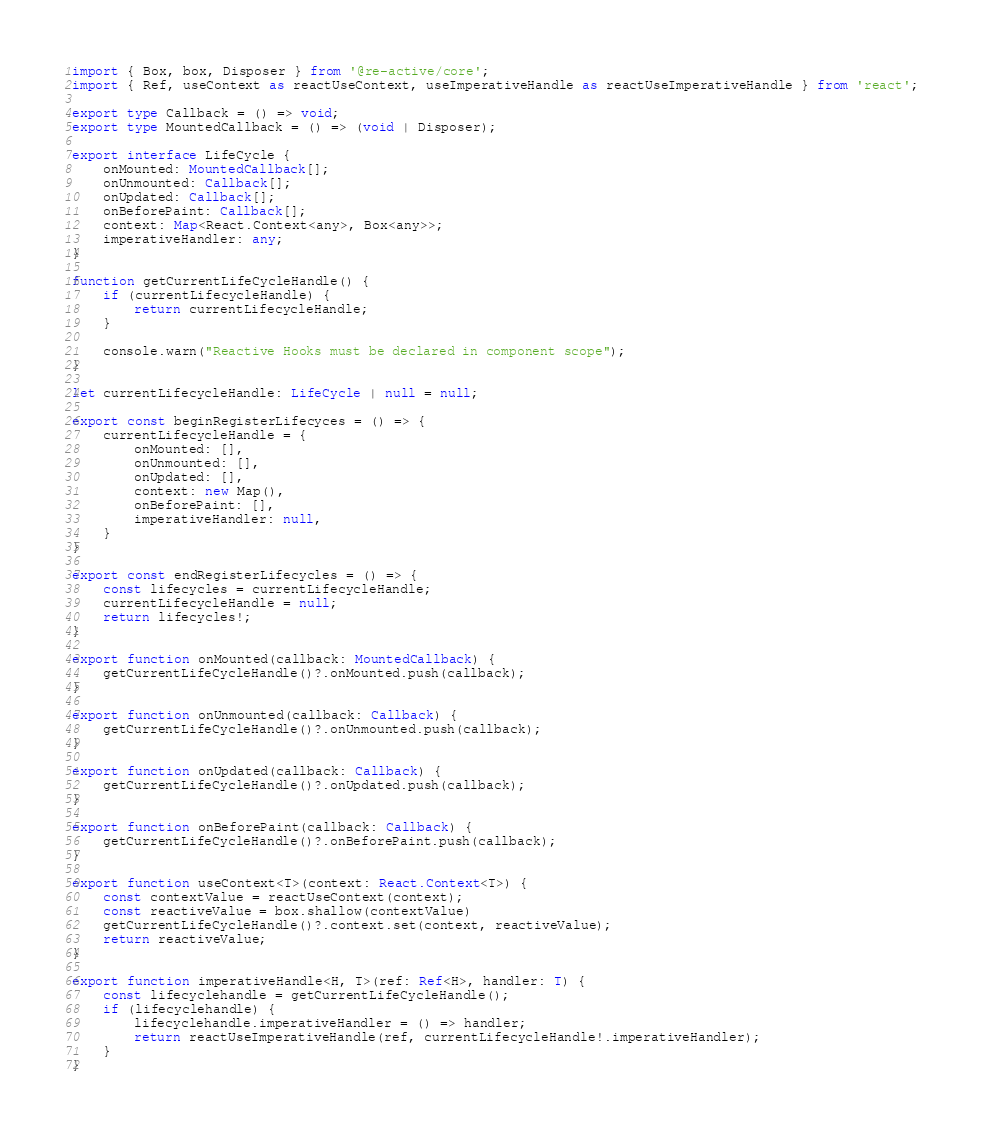Convert code to text. <code><loc_0><loc_0><loc_500><loc_500><_TypeScript_>import { Box, box, Disposer } from '@re-active/core';
import { Ref, useContext as reactUseContext, useImperativeHandle as reactUseImperativeHandle } from 'react';

export type Callback = () => void;
export type MountedCallback = () => (void | Disposer);

export interface LifeCycle {
    onMounted: MountedCallback[];
    onUnmounted: Callback[];
    onUpdated: Callback[];
    onBeforePaint: Callback[];
    context: Map<React.Context<any>, Box<any>>;
    imperativeHandler: any;
}

function getCurrentLifeCycleHandle() {
    if (currentLifecycleHandle) {
        return currentLifecycleHandle;   
    }

    console.warn("Reactive Hooks must be declared in component scope");
}

let currentLifecycleHandle: LifeCycle | null = null;

export const beginRegisterLifecyces = () => {
    currentLifecycleHandle = {
        onMounted: [],
        onUnmounted: [],
        onUpdated: [],
        context: new Map(),
        onBeforePaint: [],
        imperativeHandler: null,
    }
}

export const endRegisterLifecycles = () => {
    const lifecycles = currentLifecycleHandle;
    currentLifecycleHandle = null;
    return lifecycles!;
}

export function onMounted(callback: MountedCallback) {
    getCurrentLifeCycleHandle()?.onMounted.push(callback);
}

export function onUnmounted(callback: Callback) {
    getCurrentLifeCycleHandle()?.onUnmounted.push(callback);
}

export function onUpdated(callback: Callback) {
    getCurrentLifeCycleHandle()?.onUpdated.push(callback);
}

export function onBeforePaint(callback: Callback) {
    getCurrentLifeCycleHandle()?.onBeforePaint.push(callback);
}

export function useContext<T>(context: React.Context<T>) {
    const contextValue = reactUseContext(context);
    const reactiveValue = box.shallow(contextValue)
    getCurrentLifeCycleHandle()?.context.set(context, reactiveValue);
    return reactiveValue;
}

export function imperativeHandle<H, T>(ref: Ref<H>, handler: T) {
    const lifecyclehandle = getCurrentLifeCycleHandle();
    if (lifecyclehandle) {
        lifecyclehandle.imperativeHandler = () => handler;
        return reactUseImperativeHandle(ref, currentLifecycleHandle!.imperativeHandler);
    }
}
</code> 